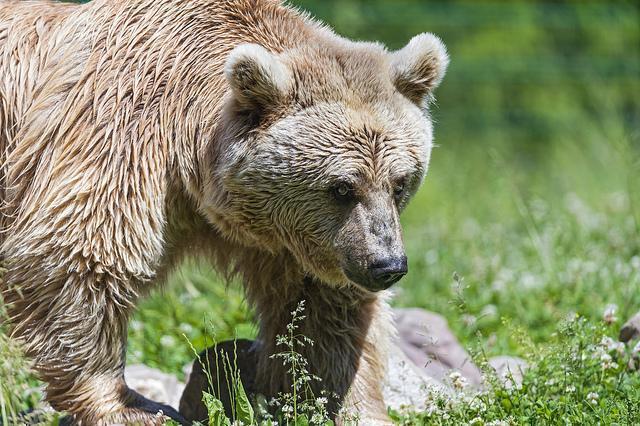How many bears can be seen?
Give a very brief answer. 1. 